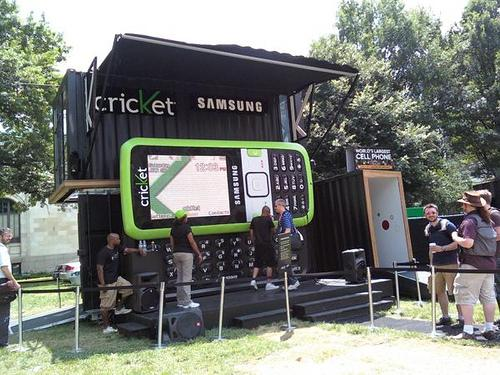Behance network has done most projects on which mobile?

Choices:
A) samsung
B) nokia
C) lenovo
D) lg samsung 